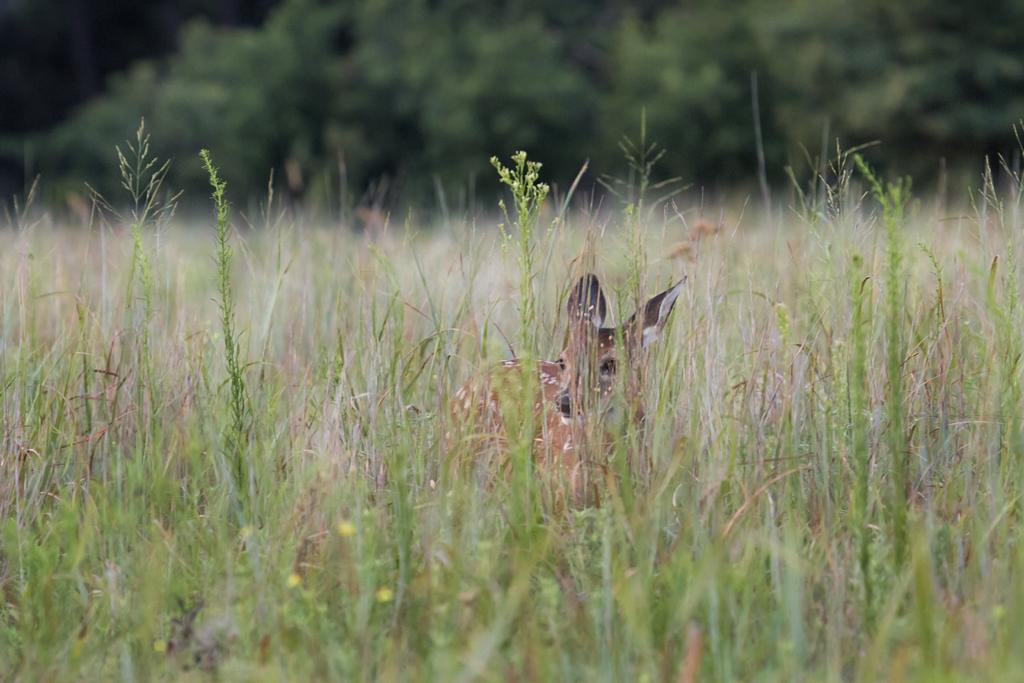Please provide a concise description of this image. In this image I can see an animal and the animal is in brown color, background I can see trees and plants in green color. 